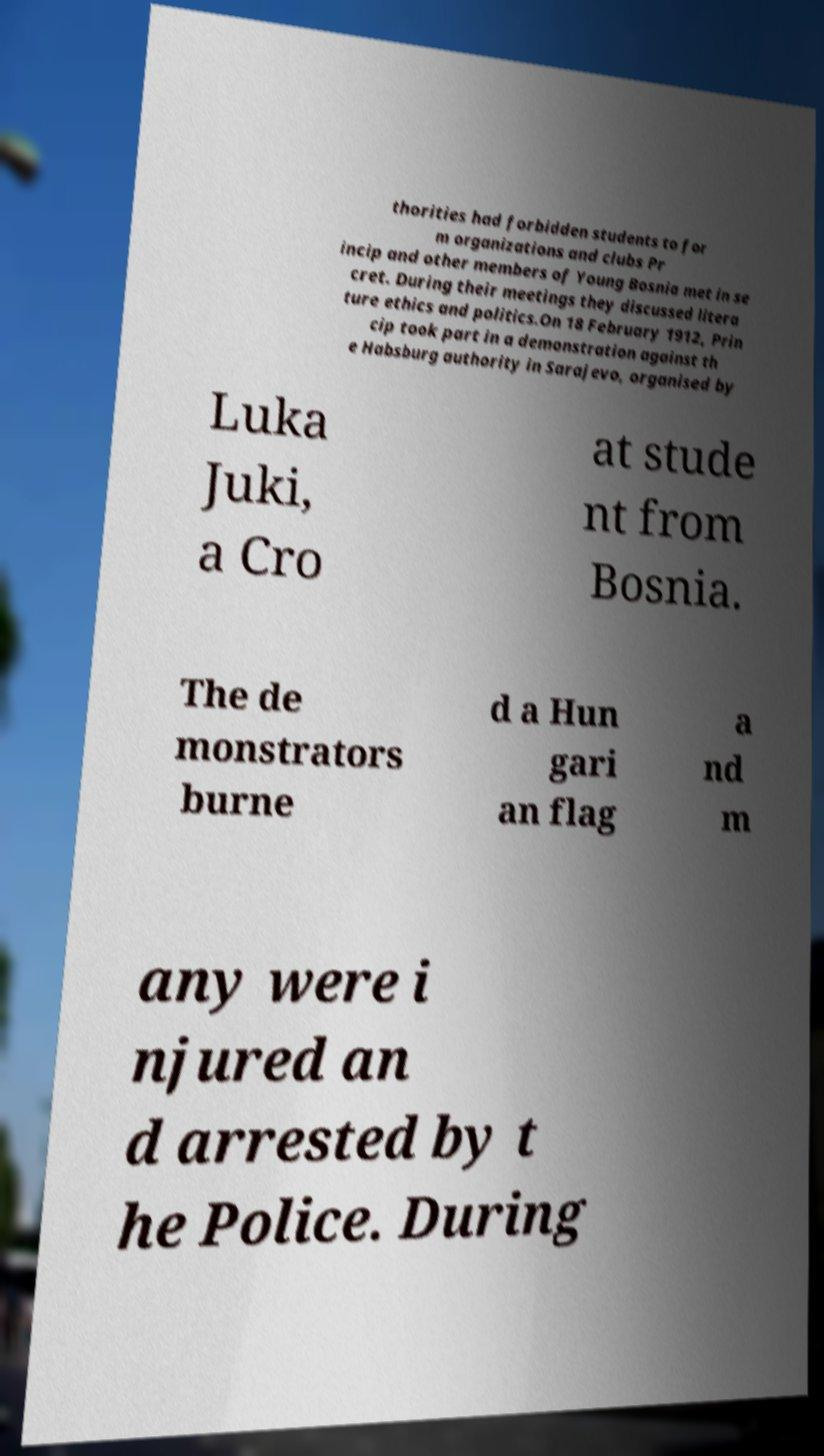Could you extract and type out the text from this image? thorities had forbidden students to for m organizations and clubs Pr incip and other members of Young Bosnia met in se cret. During their meetings they discussed litera ture ethics and politics.On 18 February 1912, Prin cip took part in a demonstration against th e Habsburg authority in Sarajevo, organised by Luka Juki, a Cro at stude nt from Bosnia. The de monstrators burne d a Hun gari an flag a nd m any were i njured an d arrested by t he Police. During 